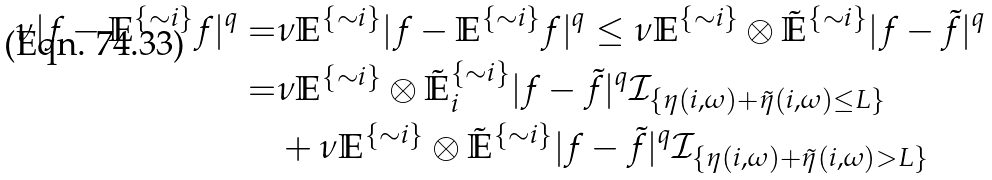Convert formula to latex. <formula><loc_0><loc_0><loc_500><loc_500>\nu | f - \mathbb { E } ^ { \{ \sim i \} } f | ^ { q } = & \nu \mathbb { E } ^ { \{ \sim i \} } | f - \mathbb { E } ^ { \{ \sim i \} } f | ^ { q } \leq \nu \mathbb { E } ^ { \{ \sim i \} } \otimes \mathbb { \tilde { E } } ^ { \{ \sim i \} } | f - \tilde { f } | ^ { q } \\ = & \nu \mathbb { E } ^ { \{ \sim i \} } \otimes \mathbb { \tilde { E } } ^ { \{ \sim i \} } _ { i } | f - \tilde { f } | ^ { q } \mathcal { I } _ { \{ \eta ( i , \omega ) + \tilde { \eta } ( i , \omega ) \leq L \} } \\ & + \nu \mathbb { E } ^ { \{ \sim i \} } \otimes \mathbb { \tilde { E } } ^ { \{ \sim i \} } | f - \tilde { f } | ^ { q } \mathbb { \mathcal { I } } _ { \{ \eta ( i , \omega ) + \tilde { \eta } ( i , \omega ) > L \} }</formula> 